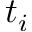Convert formula to latex. <formula><loc_0><loc_0><loc_500><loc_500>t _ { i }</formula> 